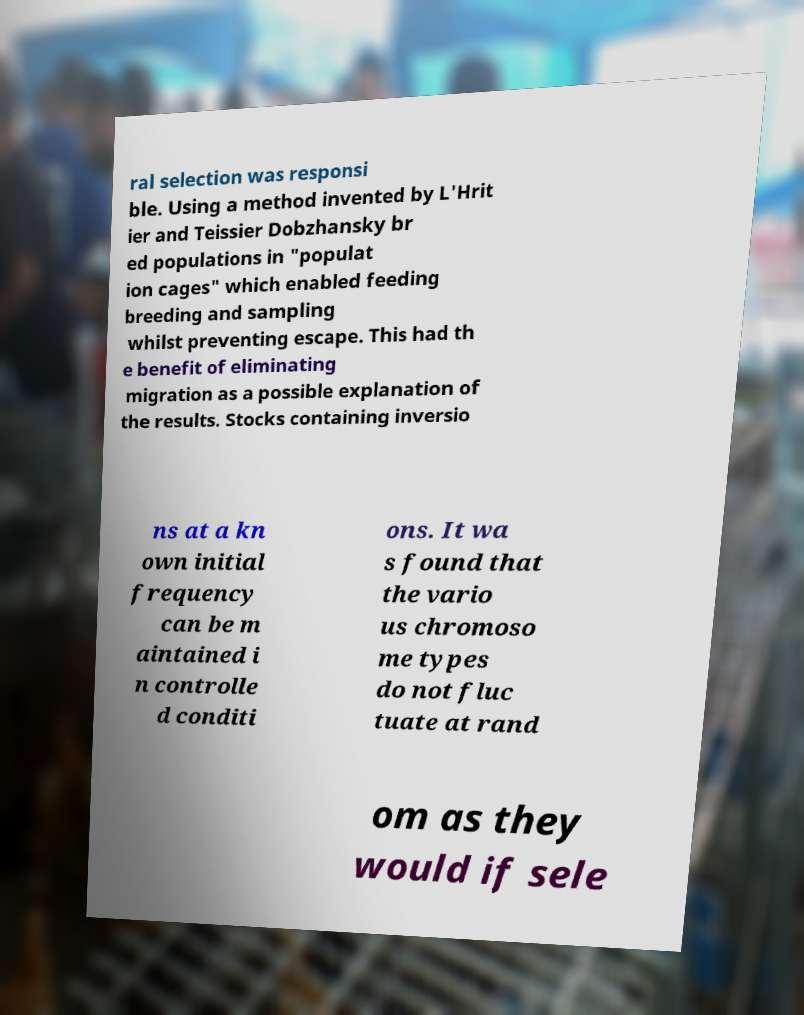Could you extract and type out the text from this image? ral selection was responsi ble. Using a method invented by L'Hrit ier and Teissier Dobzhansky br ed populations in "populat ion cages" which enabled feeding breeding and sampling whilst preventing escape. This had th e benefit of eliminating migration as a possible explanation of the results. Stocks containing inversio ns at a kn own initial frequency can be m aintained i n controlle d conditi ons. It wa s found that the vario us chromoso me types do not fluc tuate at rand om as they would if sele 